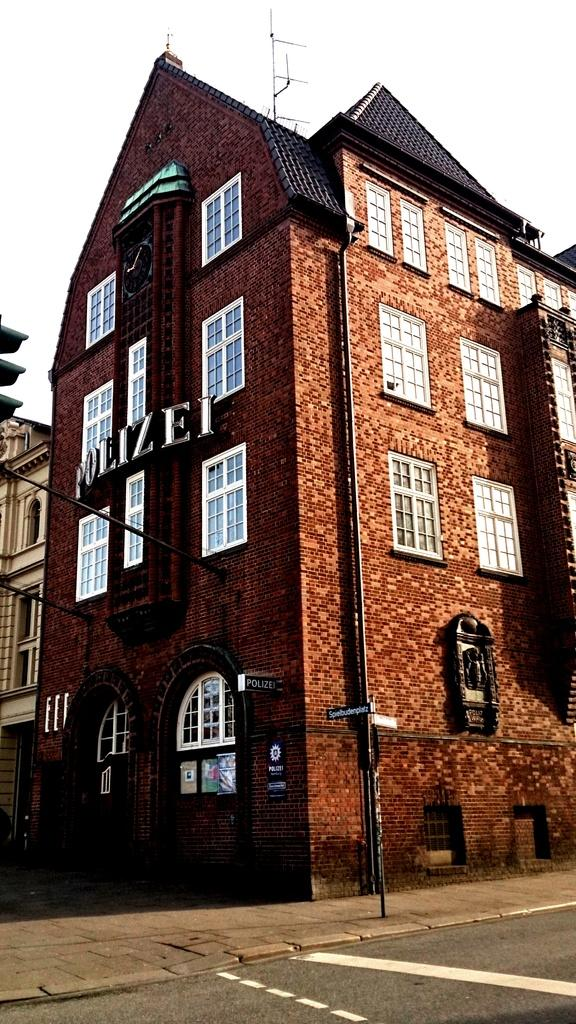What type of structures can be seen in the image? There are buildings in the image. What are the boards used for in the image? The purpose of the boards in the image is not specified, but they are present. How are the poles connected to the buildings? Poles are attached to the buildings in the image. What is the traffic control device in the image? A traffic light is present in the image. What type of surface is visible in the image? There is a pavement in the image. What type of pathway is visible in the image? There is a road in the image. What can be seen in the background of the image? The sky is visible in the background of the image. What type of substance is being transported by the station in the image? There is no station present in the image, so it is not possible to determine what type of substance might be transported. 